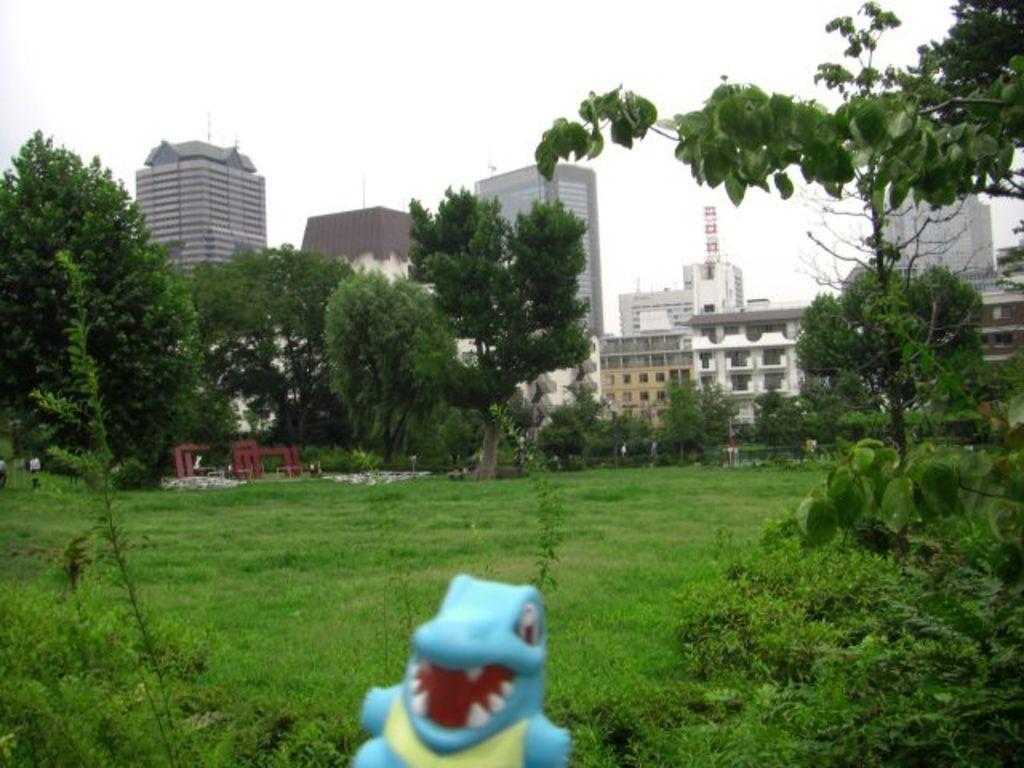Describe this image in one or two sentences. In this picture we can see trees, plants, buildings and grass. We can also see a toy.  